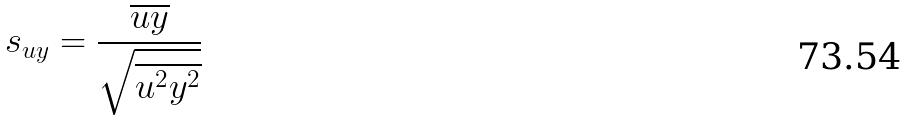<formula> <loc_0><loc_0><loc_500><loc_500>s _ { u y } = \frac { \overline { u y } } { \sqrt { \overline { u ^ { 2 } } \overline { y ^ { 2 } } } }</formula> 